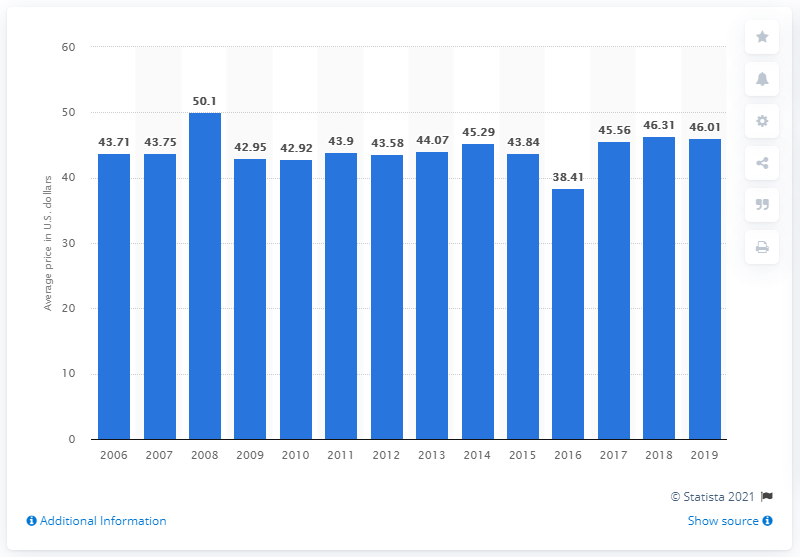Specify some key components in this picture. The average cost of acrylic nails in the United States is $46.01. 